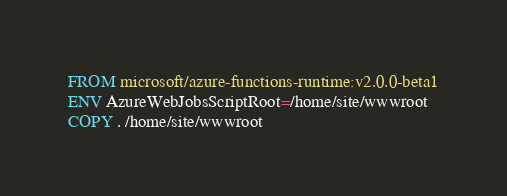<code> <loc_0><loc_0><loc_500><loc_500><_Dockerfile_>FROM microsoft/azure-functions-runtime:v2.0.0-beta1
ENV AzureWebJobsScriptRoot=/home/site/wwwroot
COPY . /home/site/wwwroot</code> 